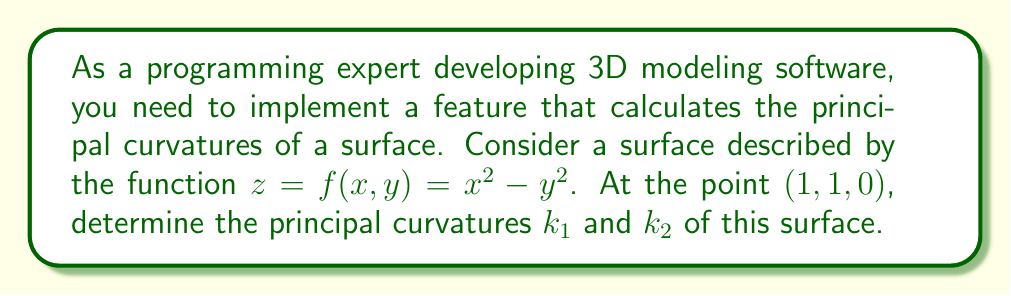Provide a solution to this math problem. To find the principal curvatures, we'll follow these steps:

1) First, we need to calculate the first and second partial derivatives of $f(x,y)$:

   $f_x = 2x$, $f_y = -2y$
   $f_{xx} = 2$, $f_{yy} = -2$, $f_{xy} = f_{yx} = 0$

2) At the point (1, 1, 0), these values are:

   $f_x = 2$, $f_y = -2$
   $f_{xx} = 2$, $f_{yy} = -2$, $f_{xy} = 0$

3) Next, we calculate the coefficients of the first fundamental form:

   $E = 1 + f_x^2 = 1 + 4 = 5$
   $F = f_x f_y = 2(-2) = -4$
   $G = 1 + f_y^2 = 1 + 4 = 5$

4) Now, we calculate the coefficients of the second fundamental form:

   $L = \frac{f_{xx}}{\sqrt{1+f_x^2+f_y^2}} = \frac{2}{\sqrt{1+4+4}} = \frac{2}{3}$
   $M = \frac{f_{xy}}{\sqrt{1+f_x^2+f_y^2}} = 0$
   $N = \frac{f_{yy}}{\sqrt{1+f_x^2+f_y^2}} = \frac{-2}{\sqrt{1+4+4}} = -\frac{2}{3}$

5) The principal curvatures are the eigenvalues of the shape operator, which can be found by solving:

   $\det\begin{pmatrix}
   L-kE & M-kF \\
   M-kF & N-kG
   \end{pmatrix} = 0$

6) Substituting our values:

   $\det\begin{pmatrix}
   \frac{2}{3}-5k & 4k \\
   4k & -\frac{2}{3}-5k
   \end{pmatrix} = 0$

7) Expanding this determinant:

   $(\frac{2}{3}-5k)(-\frac{2}{3}-5k) - 16k^2 = 0$

8) Simplifying:

   $-\frac{4}{9} - \frac{10k}{3} + 25k^2 - 16k^2 = 0$
   $9k^2 - \frac{10k}{3} - \frac{4}{9} = 0$

9) Solving this quadratic equation:

   $k = \frac{5 \pm 3\sqrt{5}}{27}$

Therefore, the principal curvatures are:

$k_1 = \frac{5 + 3\sqrt{5}}{27}$ and $k_2 = \frac{5 - 3\sqrt{5}}{27}$
Answer: $k_1 = \frac{5 + 3\sqrt{5}}{27}$, $k_2 = \frac{5 - 3\sqrt{5}}{27}$ 